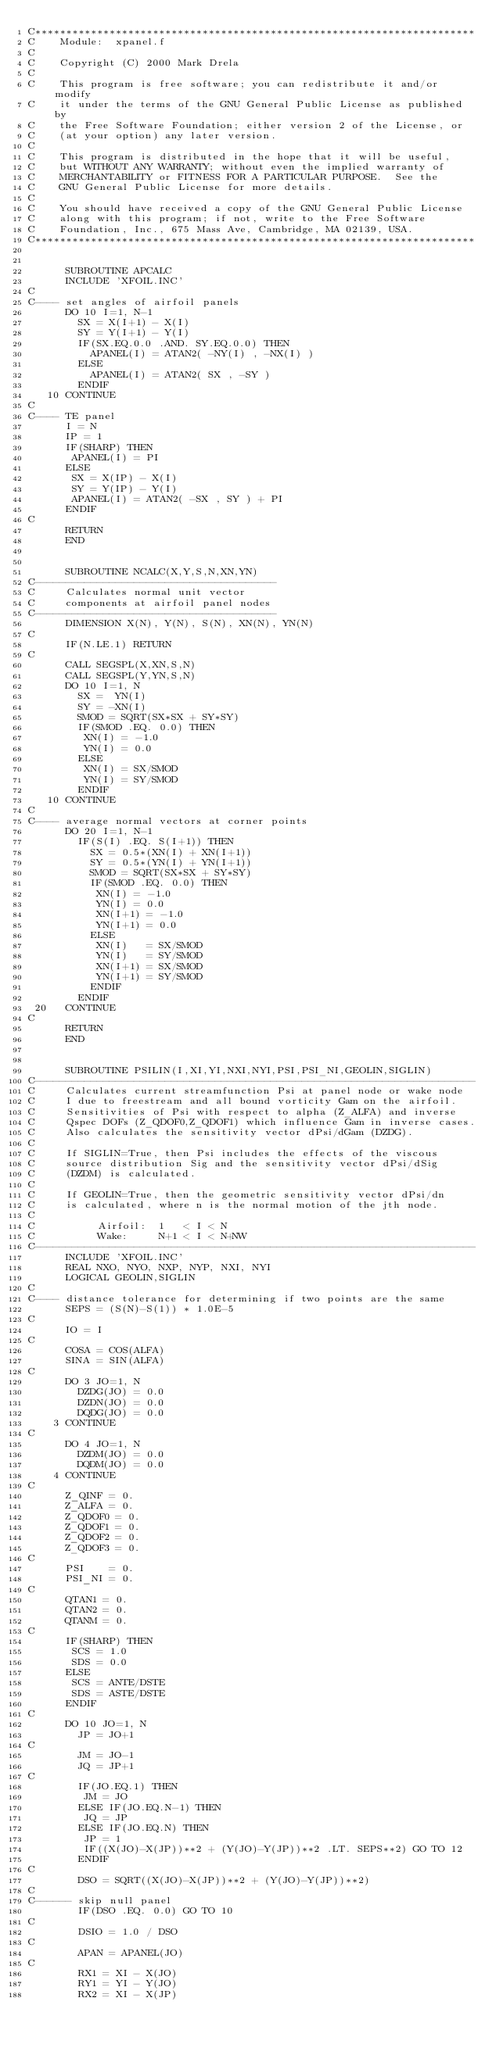<code> <loc_0><loc_0><loc_500><loc_500><_FORTRAN_>C***********************************************************************
C    Module:  xpanel.f
C 
C    Copyright (C) 2000 Mark Drela 
C 
C    This program is free software; you can redistribute it and/or modify
C    it under the terms of the GNU General Public License as published by
C    the Free Software Foundation; either version 2 of the License, or
C    (at your option) any later version.
C
C    This program is distributed in the hope that it will be useful,
C    but WITHOUT ANY WARRANTY; without even the implied warranty of
C    MERCHANTABILITY or FITNESS FOR A PARTICULAR PURPOSE.  See the
C    GNU General Public License for more details.
C
C    You should have received a copy of the GNU General Public License
C    along with this program; if not, write to the Free Software
C    Foundation, Inc., 675 Mass Ave, Cambridge, MA 02139, USA.
C***********************************************************************


      SUBROUTINE APCALC
      INCLUDE 'XFOIL.INC'
C
C---- set angles of airfoil panels
      DO 10 I=1, N-1
        SX = X(I+1) - X(I)
        SY = Y(I+1) - Y(I)
        IF(SX.EQ.0.0 .AND. SY.EQ.0.0) THEN
          APANEL(I) = ATAN2( -NY(I) , -NX(I) )
        ELSE
          APANEL(I) = ATAN2( SX , -SY )
        ENDIF
   10 CONTINUE
C
C---- TE panel
      I = N
      IP = 1
      IF(SHARP) THEN
       APANEL(I) = PI
      ELSE
       SX = X(IP) - X(I)
       SY = Y(IP) - Y(I)
       APANEL(I) = ATAN2( -SX , SY ) + PI
      ENDIF
C
      RETURN
      END
 
 
      SUBROUTINE NCALC(X,Y,S,N,XN,YN)
C---------------------------------------
C     Calculates normal unit vector
C     components at airfoil panel nodes
C---------------------------------------
      DIMENSION X(N), Y(N), S(N), XN(N), YN(N)
C
      IF(N.LE.1) RETURN
C
      CALL SEGSPL(X,XN,S,N)
      CALL SEGSPL(Y,YN,S,N)
      DO 10 I=1, N
        SX =  YN(I)
        SY = -XN(I)
        SMOD = SQRT(SX*SX + SY*SY)
        IF(SMOD .EQ. 0.0) THEN
         XN(I) = -1.0
         YN(I) = 0.0
        ELSE
         XN(I) = SX/SMOD
         YN(I) = SY/SMOD
        ENDIF
   10 CONTINUE
C
C---- average normal vectors at corner points
      DO 20 I=1, N-1
        IF(S(I) .EQ. S(I+1)) THEN
          SX = 0.5*(XN(I) + XN(I+1))
          SY = 0.5*(YN(I) + YN(I+1))
          SMOD = SQRT(SX*SX + SY*SY)
          IF(SMOD .EQ. 0.0) THEN
           XN(I) = -1.0
           YN(I) = 0.0
           XN(I+1) = -1.0
           YN(I+1) = 0.0
          ELSE
           XN(I)   = SX/SMOD
           YN(I)   = SY/SMOD
           XN(I+1) = SX/SMOD
           YN(I+1) = SY/SMOD
          ENDIF
        ENDIF
 20   CONTINUE
C
      RETURN
      END

 
      SUBROUTINE PSILIN(I,XI,YI,NXI,NYI,PSI,PSI_NI,GEOLIN,SIGLIN)
C-----------------------------------------------------------------------
C     Calculates current streamfunction Psi at panel node or wake node
C     I due to freestream and all bound vorticity Gam on the airfoil. 
C     Sensitivities of Psi with respect to alpha (Z_ALFA) and inverse
C     Qspec DOFs (Z_QDOF0,Z_QDOF1) which influence Gam in inverse cases.
C     Also calculates the sensitivity vector dPsi/dGam (DZDG).
C
C     If SIGLIN=True, then Psi includes the effects of the viscous
C     source distribution Sig and the sensitivity vector dPsi/dSig
C     (DZDM) is calculated.
C
C     If GEOLIN=True, then the geometric sensitivity vector dPsi/dn
C     is calculated, where n is the normal motion of the jth node.
C
C          Airfoil:  1   < I < N
C          Wake:     N+1 < I < N+NW
C-----------------------------------------------------------------------
      INCLUDE 'XFOIL.INC'
      REAL NXO, NYO, NXP, NYP, NXI, NYI
      LOGICAL GEOLIN,SIGLIN
C
C---- distance tolerance for determining if two points are the same
      SEPS = (S(N)-S(1)) * 1.0E-5
C
      IO = I
C
      COSA = COS(ALFA)
      SINA = SIN(ALFA)
C
      DO 3 JO=1, N
        DZDG(JO) = 0.0
        DZDN(JO) = 0.0
        DQDG(JO) = 0.0
    3 CONTINUE
C
      DO 4 JO=1, N
        DZDM(JO) = 0.0
        DQDM(JO) = 0.0
    4 CONTINUE
C
      Z_QINF = 0.
      Z_ALFA = 0.
      Z_QDOF0 = 0.
      Z_QDOF1 = 0.
      Z_QDOF2 = 0.
      Z_QDOF3 = 0.
C
      PSI    = 0.
      PSI_NI = 0.
C
      QTAN1 = 0.
      QTAN2 = 0.
      QTANM = 0.
C
      IF(SHARP) THEN
       SCS = 1.0
       SDS = 0.0
      ELSE
       SCS = ANTE/DSTE
       SDS = ASTE/DSTE
      ENDIF
C
      DO 10 JO=1, N
        JP = JO+1
C
        JM = JO-1
        JQ = JP+1
C
        IF(JO.EQ.1) THEN
         JM = JO
        ELSE IF(JO.EQ.N-1) THEN
         JQ = JP
        ELSE IF(JO.EQ.N) THEN
         JP = 1
         IF((X(JO)-X(JP))**2 + (Y(JO)-Y(JP))**2 .LT. SEPS**2) GO TO 12
        ENDIF
C
        DSO = SQRT((X(JO)-X(JP))**2 + (Y(JO)-Y(JP))**2)
C
C------ skip null panel
        IF(DSO .EQ. 0.0) GO TO 10
C
        DSIO = 1.0 / DSO
C
        APAN = APANEL(JO)
C
        RX1 = XI - X(JO)
        RY1 = YI - Y(JO)
        RX2 = XI - X(JP)</code> 